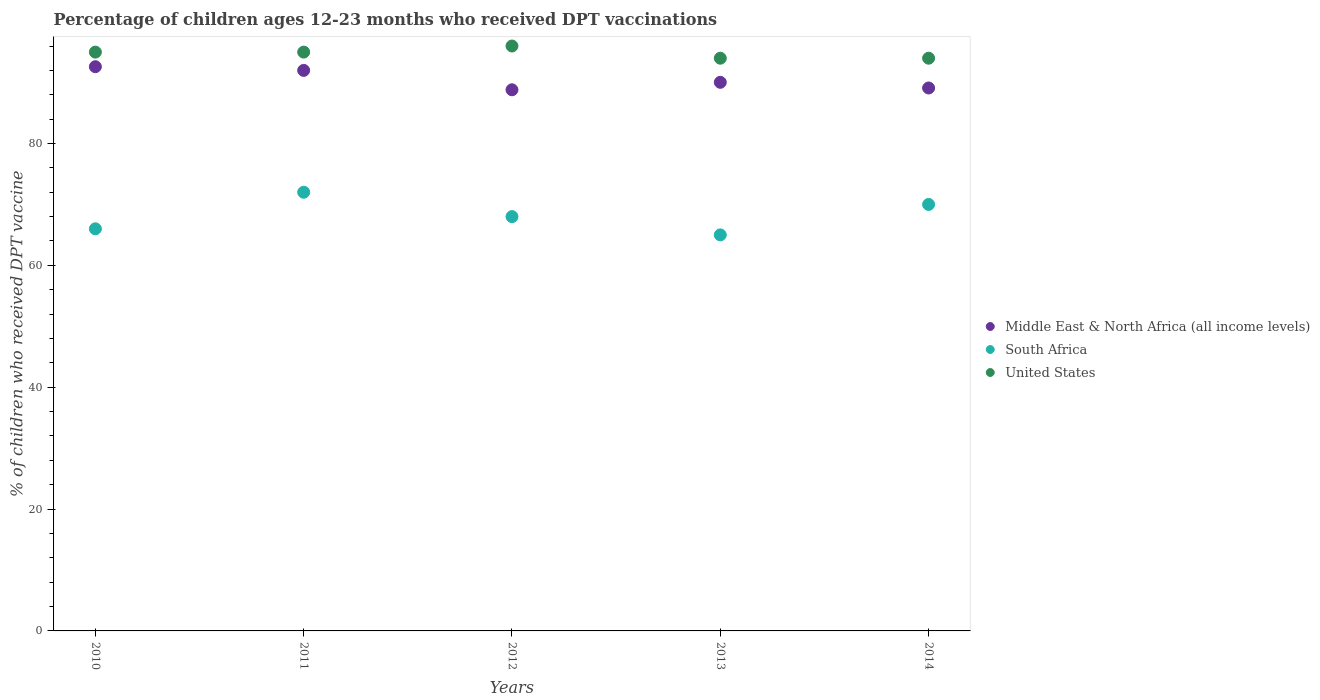What is the percentage of children who received DPT vaccination in Middle East & North Africa (all income levels) in 2011?
Provide a succinct answer. 92. Across all years, what is the minimum percentage of children who received DPT vaccination in United States?
Keep it short and to the point. 94. What is the total percentage of children who received DPT vaccination in South Africa in the graph?
Offer a terse response. 341. What is the difference between the percentage of children who received DPT vaccination in United States in 2010 and that in 2013?
Provide a succinct answer. 1. What is the difference between the percentage of children who received DPT vaccination in Middle East & North Africa (all income levels) in 2011 and the percentage of children who received DPT vaccination in South Africa in 2012?
Provide a short and direct response. 24. What is the average percentage of children who received DPT vaccination in Middle East & North Africa (all income levels) per year?
Ensure brevity in your answer.  90.51. What is the ratio of the percentage of children who received DPT vaccination in Middle East & North Africa (all income levels) in 2012 to that in 2014?
Your response must be concise. 1. What is the difference between the highest and the second highest percentage of children who received DPT vaccination in Middle East & North Africa (all income levels)?
Give a very brief answer. 0.61. In how many years, is the percentage of children who received DPT vaccination in Middle East & North Africa (all income levels) greater than the average percentage of children who received DPT vaccination in Middle East & North Africa (all income levels) taken over all years?
Keep it short and to the point. 2. Does the percentage of children who received DPT vaccination in United States monotonically increase over the years?
Give a very brief answer. No. Is the percentage of children who received DPT vaccination in United States strictly greater than the percentage of children who received DPT vaccination in South Africa over the years?
Provide a succinct answer. Yes. How many dotlines are there?
Your answer should be compact. 3. Does the graph contain grids?
Give a very brief answer. No. Where does the legend appear in the graph?
Your answer should be very brief. Center right. How many legend labels are there?
Your response must be concise. 3. What is the title of the graph?
Offer a terse response. Percentage of children ages 12-23 months who received DPT vaccinations. What is the label or title of the X-axis?
Provide a short and direct response. Years. What is the label or title of the Y-axis?
Your response must be concise. % of children who received DPT vaccine. What is the % of children who received DPT vaccine in Middle East & North Africa (all income levels) in 2010?
Make the answer very short. 92.6. What is the % of children who received DPT vaccine in United States in 2010?
Your answer should be very brief. 95. What is the % of children who received DPT vaccine in Middle East & North Africa (all income levels) in 2011?
Offer a terse response. 92. What is the % of children who received DPT vaccine of Middle East & North Africa (all income levels) in 2012?
Offer a terse response. 88.82. What is the % of children who received DPT vaccine in United States in 2012?
Give a very brief answer. 96. What is the % of children who received DPT vaccine of Middle East & North Africa (all income levels) in 2013?
Provide a short and direct response. 90.04. What is the % of children who received DPT vaccine in South Africa in 2013?
Offer a terse response. 65. What is the % of children who received DPT vaccine in United States in 2013?
Offer a very short reply. 94. What is the % of children who received DPT vaccine in Middle East & North Africa (all income levels) in 2014?
Provide a short and direct response. 89.11. What is the % of children who received DPT vaccine of South Africa in 2014?
Your response must be concise. 70. What is the % of children who received DPT vaccine of United States in 2014?
Make the answer very short. 94. Across all years, what is the maximum % of children who received DPT vaccine in Middle East & North Africa (all income levels)?
Offer a terse response. 92.6. Across all years, what is the maximum % of children who received DPT vaccine of United States?
Your answer should be very brief. 96. Across all years, what is the minimum % of children who received DPT vaccine in Middle East & North Africa (all income levels)?
Your answer should be very brief. 88.82. Across all years, what is the minimum % of children who received DPT vaccine in South Africa?
Ensure brevity in your answer.  65. Across all years, what is the minimum % of children who received DPT vaccine in United States?
Ensure brevity in your answer.  94. What is the total % of children who received DPT vaccine of Middle East & North Africa (all income levels) in the graph?
Offer a terse response. 452.57. What is the total % of children who received DPT vaccine in South Africa in the graph?
Offer a very short reply. 341. What is the total % of children who received DPT vaccine in United States in the graph?
Offer a terse response. 474. What is the difference between the % of children who received DPT vaccine of Middle East & North Africa (all income levels) in 2010 and that in 2011?
Make the answer very short. 0.61. What is the difference between the % of children who received DPT vaccine of Middle East & North Africa (all income levels) in 2010 and that in 2012?
Keep it short and to the point. 3.79. What is the difference between the % of children who received DPT vaccine of South Africa in 2010 and that in 2012?
Offer a very short reply. -2. What is the difference between the % of children who received DPT vaccine in Middle East & North Africa (all income levels) in 2010 and that in 2013?
Ensure brevity in your answer.  2.56. What is the difference between the % of children who received DPT vaccine of United States in 2010 and that in 2013?
Your answer should be very brief. 1. What is the difference between the % of children who received DPT vaccine of Middle East & North Africa (all income levels) in 2010 and that in 2014?
Your response must be concise. 3.49. What is the difference between the % of children who received DPT vaccine of South Africa in 2010 and that in 2014?
Your response must be concise. -4. What is the difference between the % of children who received DPT vaccine of Middle East & North Africa (all income levels) in 2011 and that in 2012?
Provide a succinct answer. 3.18. What is the difference between the % of children who received DPT vaccine of Middle East & North Africa (all income levels) in 2011 and that in 2013?
Your answer should be compact. 1.96. What is the difference between the % of children who received DPT vaccine in United States in 2011 and that in 2013?
Keep it short and to the point. 1. What is the difference between the % of children who received DPT vaccine in Middle East & North Africa (all income levels) in 2011 and that in 2014?
Your response must be concise. 2.89. What is the difference between the % of children who received DPT vaccine of Middle East & North Africa (all income levels) in 2012 and that in 2013?
Your answer should be very brief. -1.23. What is the difference between the % of children who received DPT vaccine of South Africa in 2012 and that in 2013?
Offer a very short reply. 3. What is the difference between the % of children who received DPT vaccine in Middle East & North Africa (all income levels) in 2012 and that in 2014?
Your response must be concise. -0.3. What is the difference between the % of children who received DPT vaccine in Middle East & North Africa (all income levels) in 2013 and that in 2014?
Provide a short and direct response. 0.93. What is the difference between the % of children who received DPT vaccine of United States in 2013 and that in 2014?
Your answer should be compact. 0. What is the difference between the % of children who received DPT vaccine in Middle East & North Africa (all income levels) in 2010 and the % of children who received DPT vaccine in South Africa in 2011?
Keep it short and to the point. 20.6. What is the difference between the % of children who received DPT vaccine in Middle East & North Africa (all income levels) in 2010 and the % of children who received DPT vaccine in United States in 2011?
Provide a short and direct response. -2.4. What is the difference between the % of children who received DPT vaccine of Middle East & North Africa (all income levels) in 2010 and the % of children who received DPT vaccine of South Africa in 2012?
Provide a succinct answer. 24.6. What is the difference between the % of children who received DPT vaccine in Middle East & North Africa (all income levels) in 2010 and the % of children who received DPT vaccine in United States in 2012?
Ensure brevity in your answer.  -3.4. What is the difference between the % of children who received DPT vaccine in South Africa in 2010 and the % of children who received DPT vaccine in United States in 2012?
Offer a very short reply. -30. What is the difference between the % of children who received DPT vaccine of Middle East & North Africa (all income levels) in 2010 and the % of children who received DPT vaccine of South Africa in 2013?
Offer a terse response. 27.6. What is the difference between the % of children who received DPT vaccine in Middle East & North Africa (all income levels) in 2010 and the % of children who received DPT vaccine in United States in 2013?
Provide a succinct answer. -1.4. What is the difference between the % of children who received DPT vaccine of South Africa in 2010 and the % of children who received DPT vaccine of United States in 2013?
Keep it short and to the point. -28. What is the difference between the % of children who received DPT vaccine in Middle East & North Africa (all income levels) in 2010 and the % of children who received DPT vaccine in South Africa in 2014?
Give a very brief answer. 22.6. What is the difference between the % of children who received DPT vaccine in Middle East & North Africa (all income levels) in 2010 and the % of children who received DPT vaccine in United States in 2014?
Ensure brevity in your answer.  -1.4. What is the difference between the % of children who received DPT vaccine of Middle East & North Africa (all income levels) in 2011 and the % of children who received DPT vaccine of South Africa in 2012?
Offer a terse response. 24. What is the difference between the % of children who received DPT vaccine in Middle East & North Africa (all income levels) in 2011 and the % of children who received DPT vaccine in United States in 2012?
Provide a short and direct response. -4. What is the difference between the % of children who received DPT vaccine in Middle East & North Africa (all income levels) in 2011 and the % of children who received DPT vaccine in South Africa in 2013?
Ensure brevity in your answer.  27. What is the difference between the % of children who received DPT vaccine of Middle East & North Africa (all income levels) in 2011 and the % of children who received DPT vaccine of United States in 2013?
Your answer should be compact. -2. What is the difference between the % of children who received DPT vaccine of South Africa in 2011 and the % of children who received DPT vaccine of United States in 2013?
Offer a terse response. -22. What is the difference between the % of children who received DPT vaccine in Middle East & North Africa (all income levels) in 2011 and the % of children who received DPT vaccine in South Africa in 2014?
Make the answer very short. 22. What is the difference between the % of children who received DPT vaccine in Middle East & North Africa (all income levels) in 2011 and the % of children who received DPT vaccine in United States in 2014?
Keep it short and to the point. -2. What is the difference between the % of children who received DPT vaccine of South Africa in 2011 and the % of children who received DPT vaccine of United States in 2014?
Give a very brief answer. -22. What is the difference between the % of children who received DPT vaccine in Middle East & North Africa (all income levels) in 2012 and the % of children who received DPT vaccine in South Africa in 2013?
Offer a very short reply. 23.82. What is the difference between the % of children who received DPT vaccine of Middle East & North Africa (all income levels) in 2012 and the % of children who received DPT vaccine of United States in 2013?
Keep it short and to the point. -5.18. What is the difference between the % of children who received DPT vaccine in Middle East & North Africa (all income levels) in 2012 and the % of children who received DPT vaccine in South Africa in 2014?
Offer a very short reply. 18.82. What is the difference between the % of children who received DPT vaccine in Middle East & North Africa (all income levels) in 2012 and the % of children who received DPT vaccine in United States in 2014?
Provide a succinct answer. -5.18. What is the difference between the % of children who received DPT vaccine of Middle East & North Africa (all income levels) in 2013 and the % of children who received DPT vaccine of South Africa in 2014?
Offer a very short reply. 20.04. What is the difference between the % of children who received DPT vaccine in Middle East & North Africa (all income levels) in 2013 and the % of children who received DPT vaccine in United States in 2014?
Your answer should be compact. -3.96. What is the average % of children who received DPT vaccine in Middle East & North Africa (all income levels) per year?
Keep it short and to the point. 90.51. What is the average % of children who received DPT vaccine of South Africa per year?
Make the answer very short. 68.2. What is the average % of children who received DPT vaccine in United States per year?
Your answer should be very brief. 94.8. In the year 2010, what is the difference between the % of children who received DPT vaccine in Middle East & North Africa (all income levels) and % of children who received DPT vaccine in South Africa?
Your answer should be very brief. 26.6. In the year 2010, what is the difference between the % of children who received DPT vaccine in Middle East & North Africa (all income levels) and % of children who received DPT vaccine in United States?
Your answer should be very brief. -2.4. In the year 2010, what is the difference between the % of children who received DPT vaccine of South Africa and % of children who received DPT vaccine of United States?
Ensure brevity in your answer.  -29. In the year 2011, what is the difference between the % of children who received DPT vaccine in Middle East & North Africa (all income levels) and % of children who received DPT vaccine in South Africa?
Your answer should be very brief. 20. In the year 2011, what is the difference between the % of children who received DPT vaccine of Middle East & North Africa (all income levels) and % of children who received DPT vaccine of United States?
Keep it short and to the point. -3. In the year 2012, what is the difference between the % of children who received DPT vaccine in Middle East & North Africa (all income levels) and % of children who received DPT vaccine in South Africa?
Offer a terse response. 20.82. In the year 2012, what is the difference between the % of children who received DPT vaccine in Middle East & North Africa (all income levels) and % of children who received DPT vaccine in United States?
Offer a terse response. -7.18. In the year 2012, what is the difference between the % of children who received DPT vaccine in South Africa and % of children who received DPT vaccine in United States?
Give a very brief answer. -28. In the year 2013, what is the difference between the % of children who received DPT vaccine of Middle East & North Africa (all income levels) and % of children who received DPT vaccine of South Africa?
Your answer should be very brief. 25.04. In the year 2013, what is the difference between the % of children who received DPT vaccine in Middle East & North Africa (all income levels) and % of children who received DPT vaccine in United States?
Your answer should be compact. -3.96. In the year 2013, what is the difference between the % of children who received DPT vaccine of South Africa and % of children who received DPT vaccine of United States?
Offer a terse response. -29. In the year 2014, what is the difference between the % of children who received DPT vaccine in Middle East & North Africa (all income levels) and % of children who received DPT vaccine in South Africa?
Make the answer very short. 19.11. In the year 2014, what is the difference between the % of children who received DPT vaccine in Middle East & North Africa (all income levels) and % of children who received DPT vaccine in United States?
Offer a terse response. -4.89. What is the ratio of the % of children who received DPT vaccine of Middle East & North Africa (all income levels) in 2010 to that in 2011?
Offer a terse response. 1.01. What is the ratio of the % of children who received DPT vaccine of United States in 2010 to that in 2011?
Keep it short and to the point. 1. What is the ratio of the % of children who received DPT vaccine of Middle East & North Africa (all income levels) in 2010 to that in 2012?
Provide a short and direct response. 1.04. What is the ratio of the % of children who received DPT vaccine in South Africa in 2010 to that in 2012?
Offer a terse response. 0.97. What is the ratio of the % of children who received DPT vaccine in United States in 2010 to that in 2012?
Give a very brief answer. 0.99. What is the ratio of the % of children who received DPT vaccine in Middle East & North Africa (all income levels) in 2010 to that in 2013?
Provide a succinct answer. 1.03. What is the ratio of the % of children who received DPT vaccine of South Africa in 2010 to that in 2013?
Provide a short and direct response. 1.02. What is the ratio of the % of children who received DPT vaccine of United States in 2010 to that in 2013?
Provide a succinct answer. 1.01. What is the ratio of the % of children who received DPT vaccine of Middle East & North Africa (all income levels) in 2010 to that in 2014?
Your answer should be compact. 1.04. What is the ratio of the % of children who received DPT vaccine in South Africa in 2010 to that in 2014?
Your response must be concise. 0.94. What is the ratio of the % of children who received DPT vaccine of United States in 2010 to that in 2014?
Make the answer very short. 1.01. What is the ratio of the % of children who received DPT vaccine of Middle East & North Africa (all income levels) in 2011 to that in 2012?
Provide a succinct answer. 1.04. What is the ratio of the % of children who received DPT vaccine in South Africa in 2011 to that in 2012?
Provide a succinct answer. 1.06. What is the ratio of the % of children who received DPT vaccine of Middle East & North Africa (all income levels) in 2011 to that in 2013?
Ensure brevity in your answer.  1.02. What is the ratio of the % of children who received DPT vaccine of South Africa in 2011 to that in 2013?
Your response must be concise. 1.11. What is the ratio of the % of children who received DPT vaccine in United States in 2011 to that in 2013?
Offer a very short reply. 1.01. What is the ratio of the % of children who received DPT vaccine in Middle East & North Africa (all income levels) in 2011 to that in 2014?
Provide a succinct answer. 1.03. What is the ratio of the % of children who received DPT vaccine of South Africa in 2011 to that in 2014?
Give a very brief answer. 1.03. What is the ratio of the % of children who received DPT vaccine of United States in 2011 to that in 2014?
Offer a terse response. 1.01. What is the ratio of the % of children who received DPT vaccine of Middle East & North Africa (all income levels) in 2012 to that in 2013?
Your answer should be very brief. 0.99. What is the ratio of the % of children who received DPT vaccine of South Africa in 2012 to that in 2013?
Your answer should be very brief. 1.05. What is the ratio of the % of children who received DPT vaccine in United States in 2012 to that in 2013?
Provide a short and direct response. 1.02. What is the ratio of the % of children who received DPT vaccine in South Africa in 2012 to that in 2014?
Provide a succinct answer. 0.97. What is the ratio of the % of children who received DPT vaccine of United States in 2012 to that in 2014?
Ensure brevity in your answer.  1.02. What is the ratio of the % of children who received DPT vaccine of Middle East & North Africa (all income levels) in 2013 to that in 2014?
Provide a succinct answer. 1.01. What is the difference between the highest and the second highest % of children who received DPT vaccine in Middle East & North Africa (all income levels)?
Offer a terse response. 0.61. What is the difference between the highest and the second highest % of children who received DPT vaccine of South Africa?
Your response must be concise. 2. What is the difference between the highest and the second highest % of children who received DPT vaccine of United States?
Offer a very short reply. 1. What is the difference between the highest and the lowest % of children who received DPT vaccine in Middle East & North Africa (all income levels)?
Make the answer very short. 3.79. What is the difference between the highest and the lowest % of children who received DPT vaccine of United States?
Provide a short and direct response. 2. 